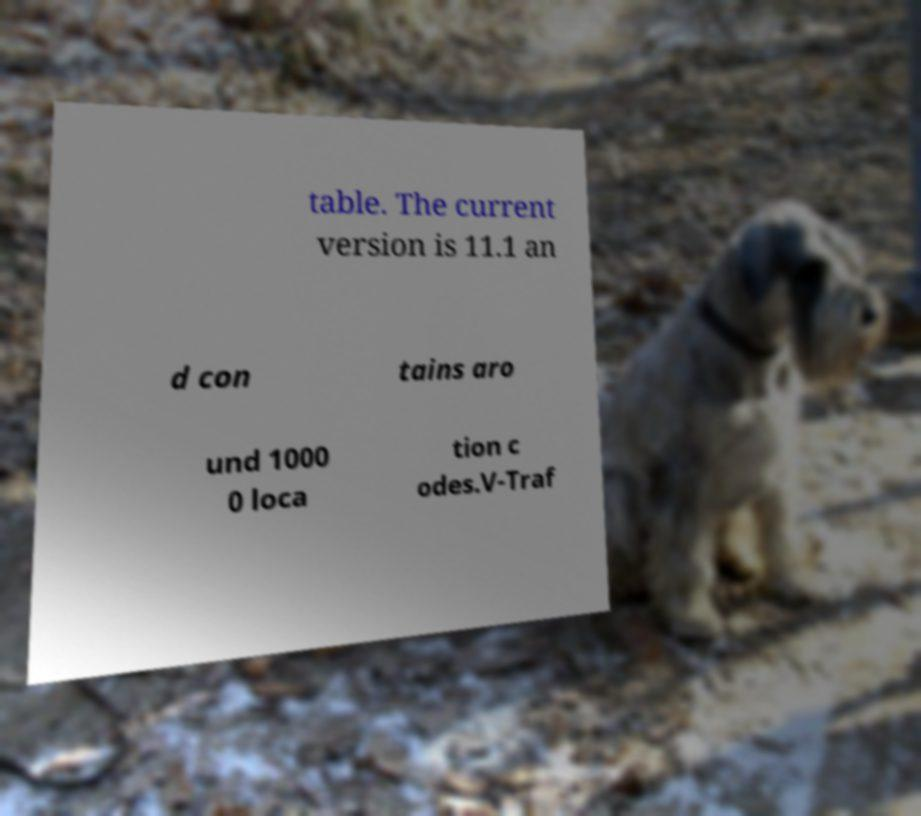What messages or text are displayed in this image? I need them in a readable, typed format. table. The current version is 11.1 an d con tains aro und 1000 0 loca tion c odes.V-Traf 